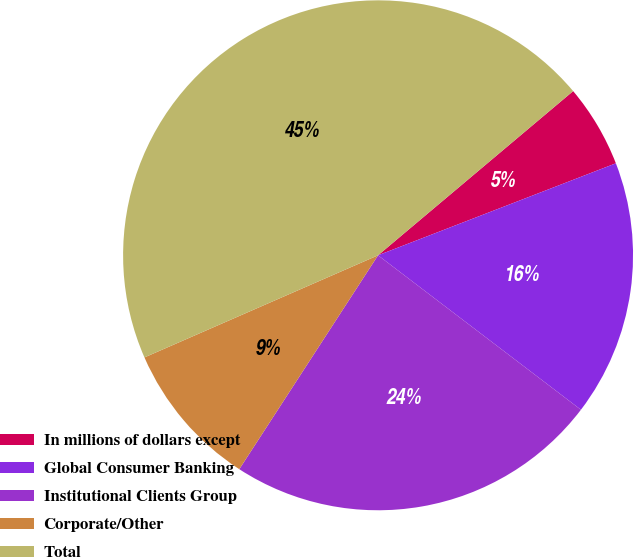Convert chart. <chart><loc_0><loc_0><loc_500><loc_500><pie_chart><fcel>In millions of dollars except<fcel>Global Consumer Banking<fcel>Institutional Clients Group<fcel>Corporate/Other<fcel>Total<nl><fcel>5.26%<fcel>16.23%<fcel>23.8%<fcel>9.28%<fcel>45.42%<nl></chart> 